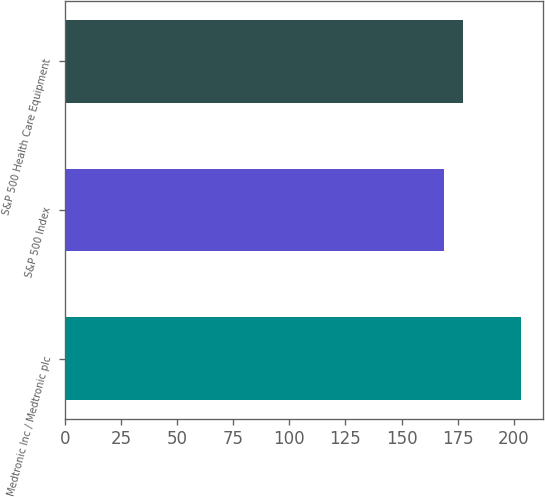<chart> <loc_0><loc_0><loc_500><loc_500><bar_chart><fcel>Medtronic Inc / Medtronic plc<fcel>S&P 500 Index<fcel>S&P 500 Health Care Equipment<nl><fcel>203.06<fcel>169.15<fcel>177.23<nl></chart> 